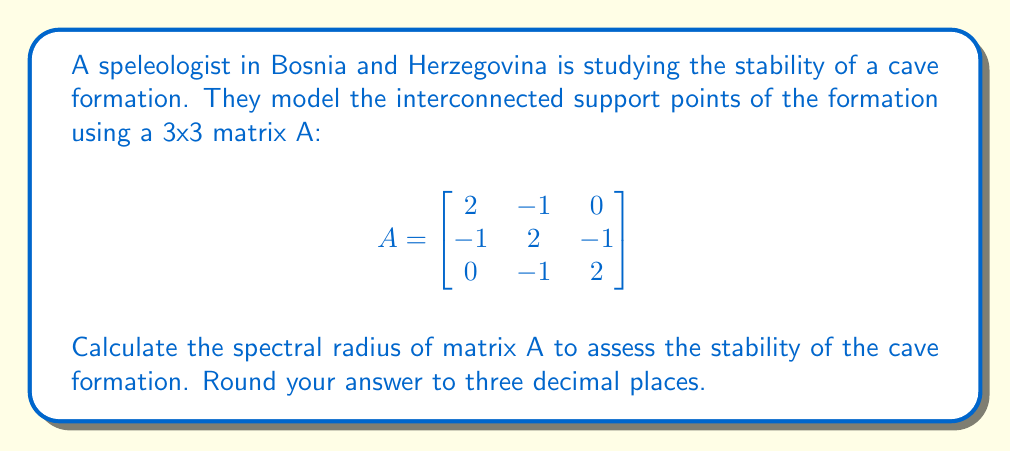Can you answer this question? To assess the stability of the cave formation using spectral analysis, we need to find the spectral radius of matrix A. The spectral radius is the maximum absolute value of the eigenvalues.

Step 1: Find the characteristic equation of matrix A.
$$det(A - \lambda I) = 0$$
$$\begin{vmatrix}
2-\lambda & -1 & 0 \\
-1 & 2-\lambda & -1 \\
0 & -1 & 2-\lambda
\end{vmatrix} = 0$$

Step 2: Expand the determinant.
$$(2-\lambda)((2-\lambda)(2-\lambda) - 1) - (-1)(-1(2-\lambda)) = 0$$
$$(2-\lambda)((2-\lambda)^2 - 1) + (2-\lambda) = 0$$
$$(2-\lambda)((2-\lambda)^2 - 1 + 1) = 0$$
$$(2-\lambda)(2-\lambda)^2 = 0$$

Step 3: Solve the characteristic equation.
$(2-\lambda) = 0$ or $(2-\lambda)^2 = 0$
$\lambda = 2$ (with algebraic multiplicity 3)

Step 4: The only eigenvalue is 2, so the spectral radius is 2.

Step 5: Round to three decimal places: 2.000

The spectral radius being 2.000 indicates that the cave formation is marginally stable. In general, a spectral radius less than 1 indicates stability, while greater than 1 indicates instability.
Answer: 2.000 